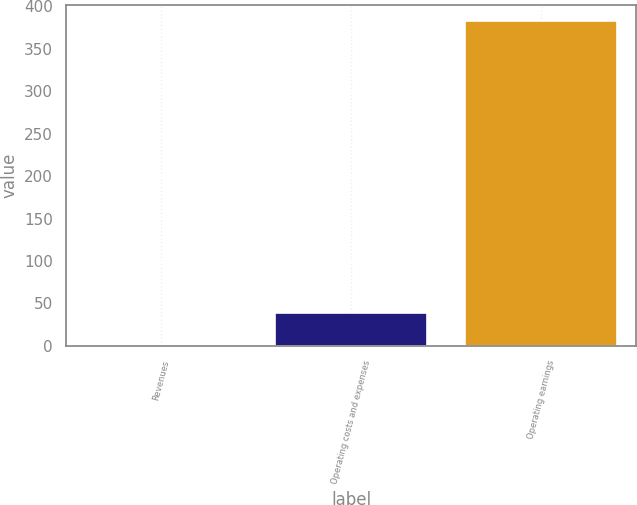<chart> <loc_0><loc_0><loc_500><loc_500><bar_chart><fcel>Revenues<fcel>Operating costs and expenses<fcel>Operating earnings<nl><fcel>0.2<fcel>38.4<fcel>382.2<nl></chart> 